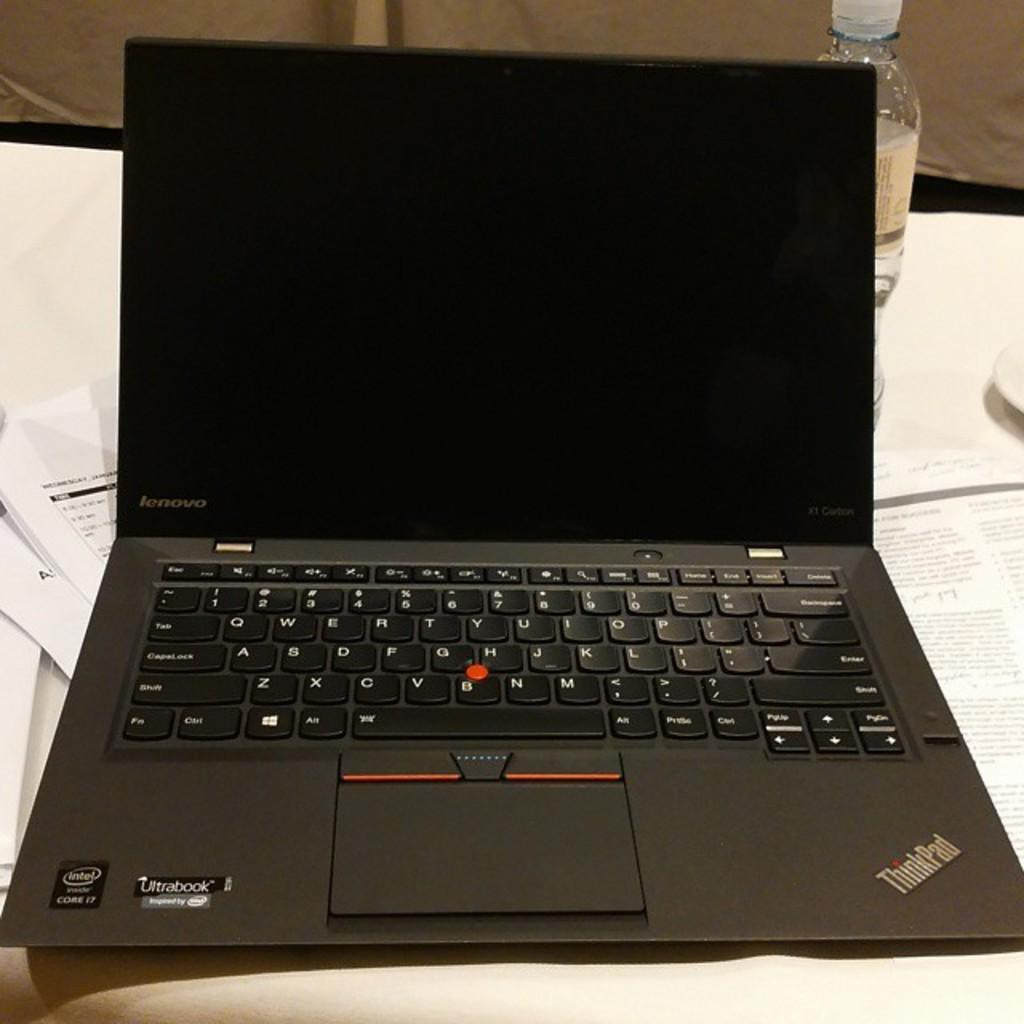<image>
Provide a brief description of the given image. A black Ultra book with the screen turned off. 